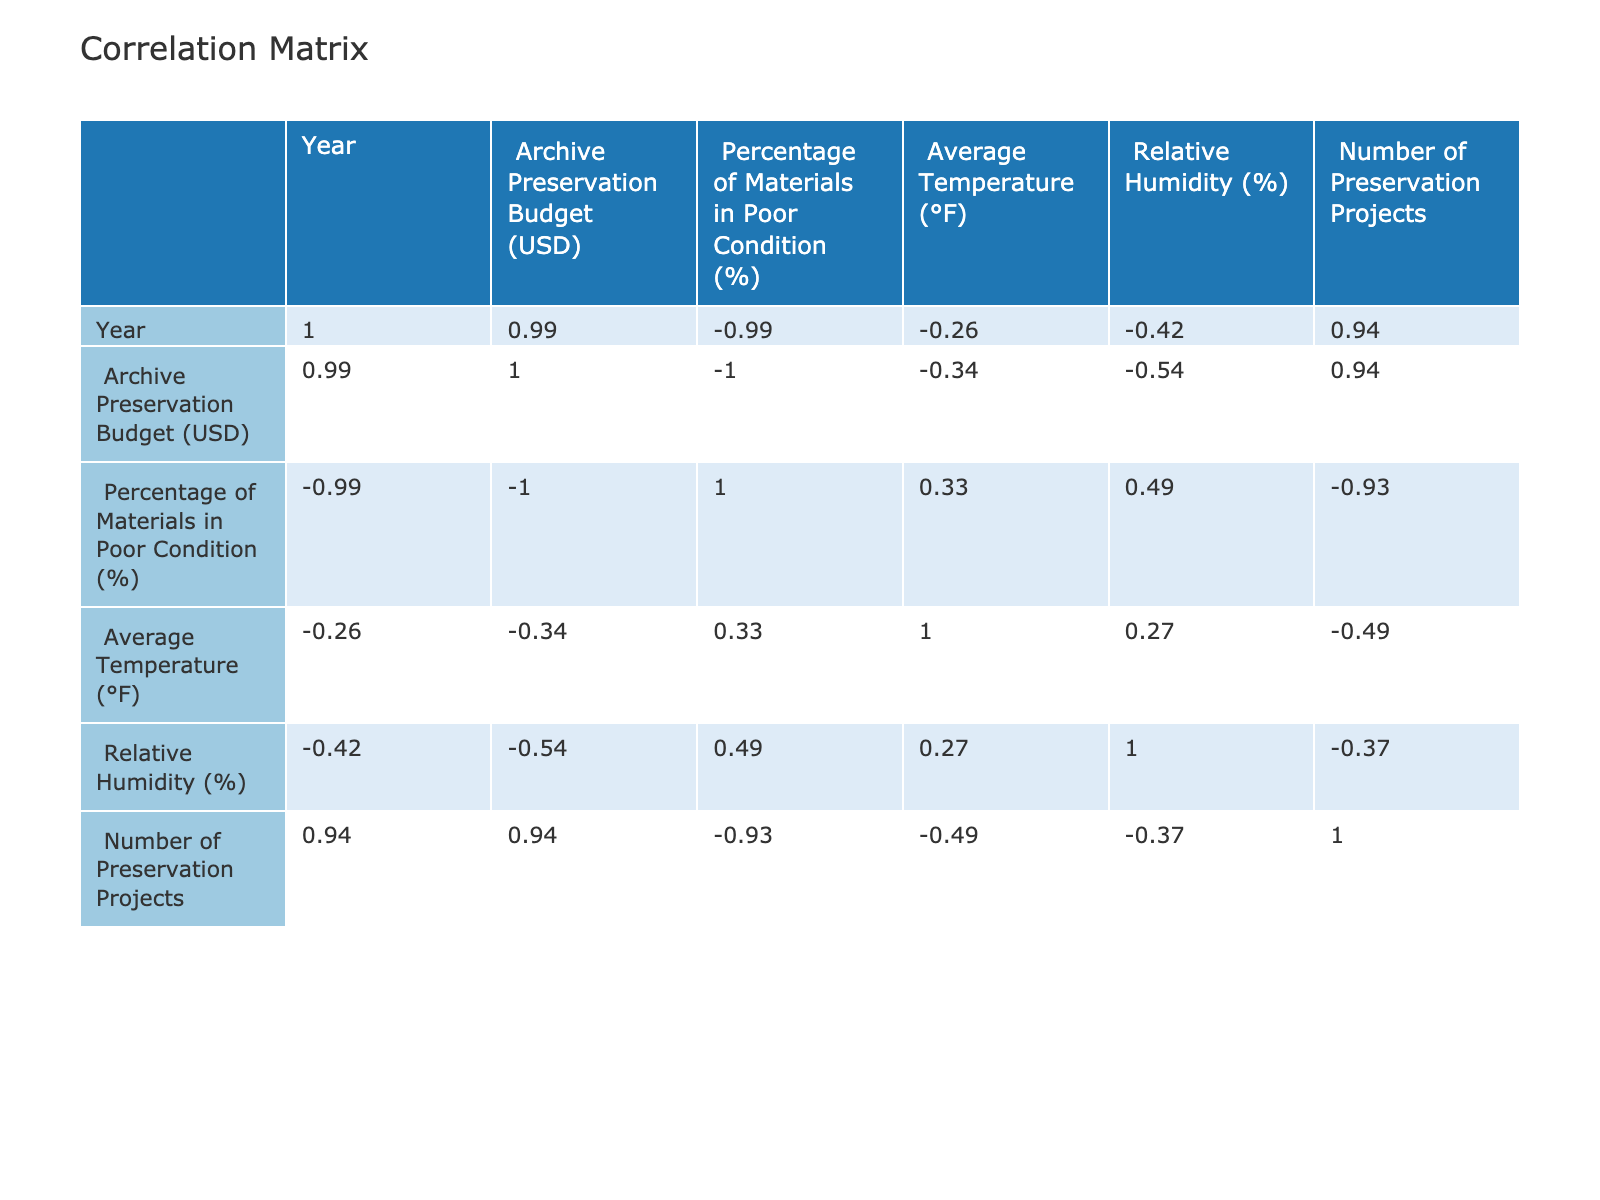What was the archive preservation budget in 2020? In the table, under the "Archive Preservation Budget (USD)" column for the year 2020, the value is directly listed as 200000.
Answer: 200000 What percentage of materials were in poor condition in 2023? Looking at the "Percentage of Materials in Poor Condition (%)" column for the year 2023, the value is 15.
Answer: 15 Is the average temperature in 2019 higher than in 2022? The average temperatures listed are 66 for 2019 and 69 for 2022. Since 66 is less than 69, the statement is false.
Answer: No What is the total budget for all years from 2018 to 2023? Adding the budgets: 150000 + 175000 + 200000 + 220000 + 250000 + 300000 = 1290000, this is the total amount spent on preservation over the six years.
Answer: 1290000 How much did the preservation budget increase from 2018 to 2023? The budget in 2018 was 150000, and in 2023 it was 300000. The increase is calculated as 300000 - 150000 = 150000.
Answer: 150000 Was the number of preservation projects in 2021 less than the average number of projects from 2018 to 2023? The number of projects for 2021 is 8. The average number from 2018 (5) to 2023 (10) calculated as (5 + 7 + 6 + 8 + 9 + 10)/6 = 7.5. Since 8 is greater than 7.5, the statement is false.
Answer: No What is the percentage decrease in materials in poor condition from 2018 to 2023? The percentage in 2018 was 30 and in 2023 it was 15. The decrease is calculated as 30 - 15 = 15, so the percentage decrease is (15/30) * 100 = 50%.
Answer: 50 What was the average relative humidity from 2018 to 2023? The relative humidity values for the years are: 45, 50, 48, 52, 46, 40. Summing them gives 45 + 50 + 48 + 52 + 46 + 40 = 281, and dividing by 6 gives an average of 281/6 ≈ 46.83.
Answer: 46.83 In what year did the percentage of materials in poor condition reach its lowest value? The table shows the lowest percentage of materials in poor condition in 2023, where it is at 15.
Answer: 2023 